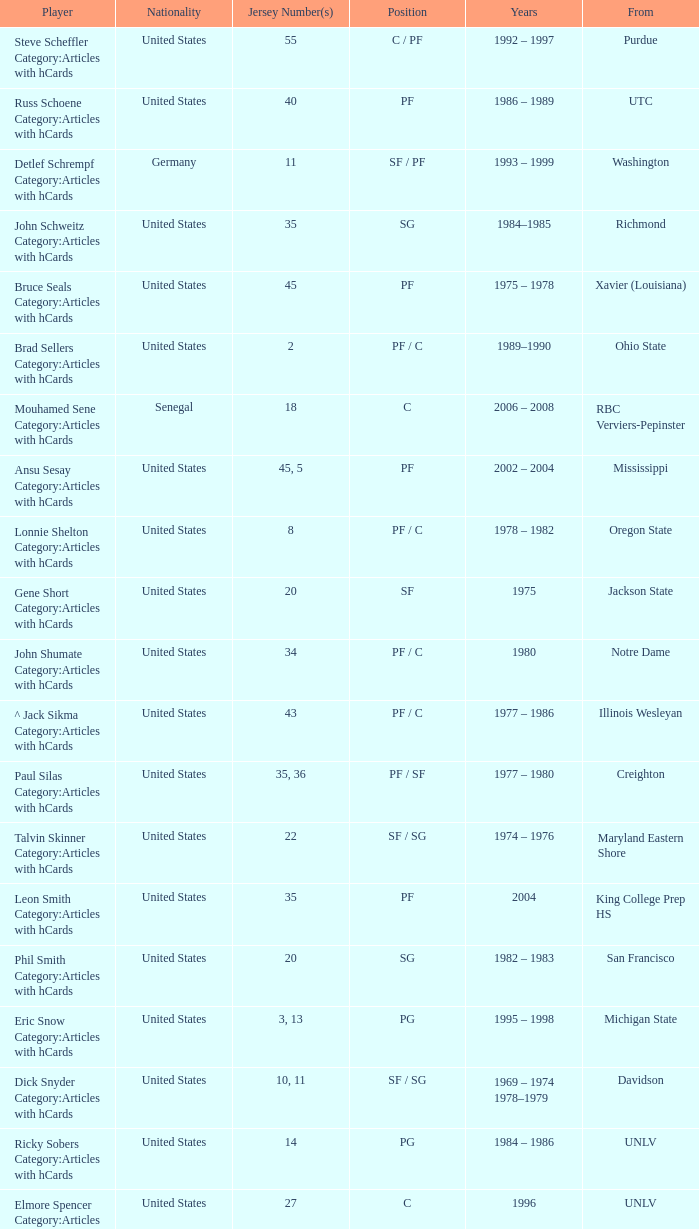What is the origin of the athlete from oregon state? United States. 